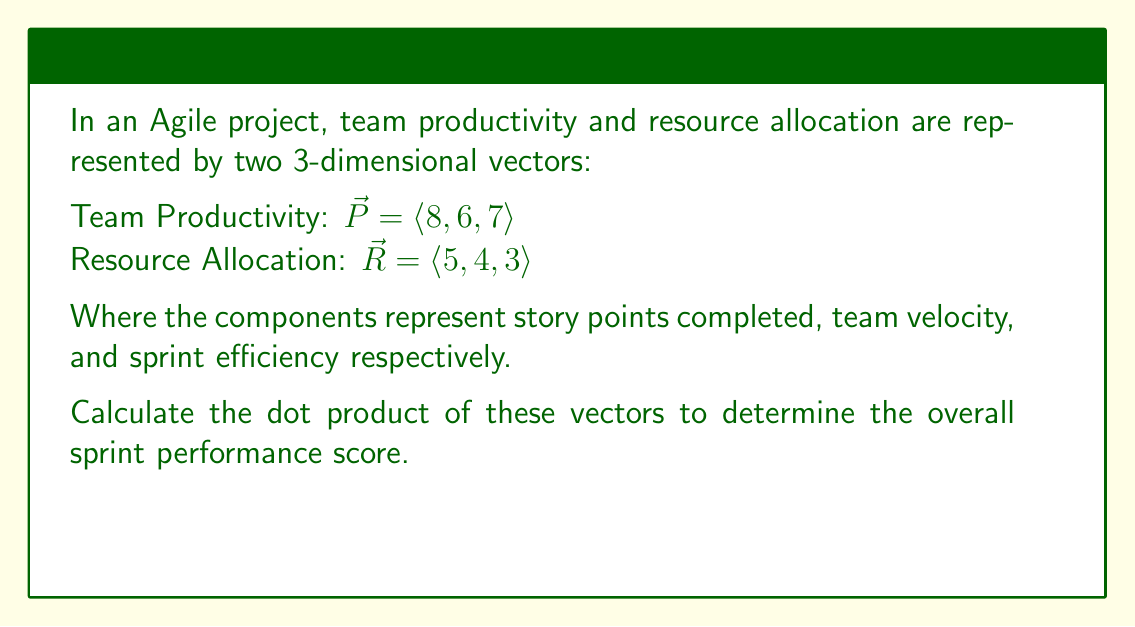Can you solve this math problem? To calculate the dot product of two vectors, we multiply the corresponding components and sum the results. The formula for the dot product of two 3D vectors $\vec{a} = \langle a_1, a_2, a_3 \rangle$ and $\vec{b} = \langle b_1, b_2, b_3 \rangle$ is:

$$\vec{a} \cdot \vec{b} = a_1b_1 + a_2b_2 + a_3b_3$$

For our vectors:
$\vec{P} = \langle 8, 6, 7 \rangle$
$\vec{R} = \langle 5, 4, 3 \rangle$

Let's calculate each component:

1. $8 \times 5 = 40$
2. $6 \times 4 = 24$
3. $7 \times 3 = 21$

Now, sum these results:

$$\vec{P} \cdot \vec{R} = 40 + 24 + 21 = 85$$

This dot product represents the overall sprint performance score, taking into account the relationship between team productivity and resource allocation in the Agile project.
Answer: $85$ 